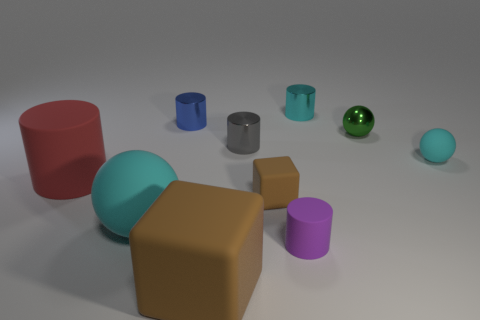What is the size of the cylinder that is both to the left of the gray metal cylinder and on the right side of the big red matte object?
Your answer should be compact. Small. There is another ball that is the same color as the big ball; what is its material?
Offer a terse response. Rubber. Are there the same number of rubber cylinders behind the small shiny ball and red balls?
Offer a terse response. Yes. Do the purple cylinder and the red thing have the same size?
Keep it short and to the point. No. What color is the rubber thing that is on the right side of the red cylinder and behind the small brown block?
Ensure brevity in your answer.  Cyan. What is the tiny blue object on the right side of the large cyan rubber thing in front of the small brown block made of?
Make the answer very short. Metal. There is a red object that is the same shape as the small cyan shiny thing; what is its size?
Make the answer very short. Large. Do the tiny thing that is behind the small blue shiny cylinder and the small rubber ball have the same color?
Provide a succinct answer. Yes. Are there fewer large purple things than balls?
Make the answer very short. Yes. How many other things are there of the same color as the tiny rubber cylinder?
Keep it short and to the point. 0. 